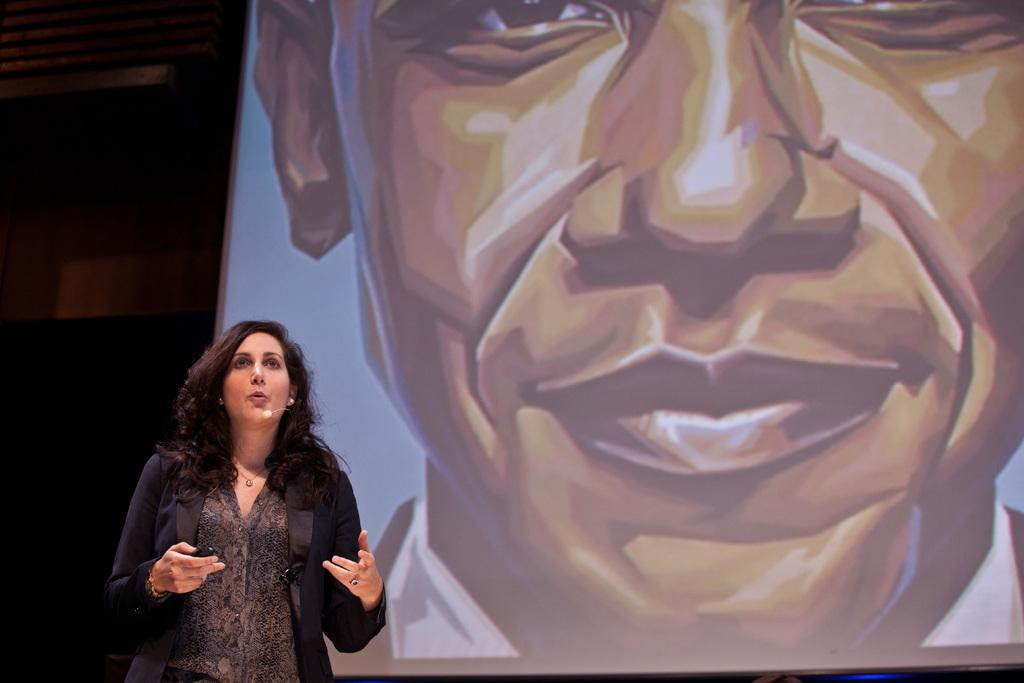What is the lady doing in the image? The lady is standing on the left side of the image. What is the lady holding in the image? The lady is holding an object in the image. What can be seen in the background of the image? There is a screen and a wall in the background of the image. How does the lady compare the size of the knot in the image? There is no knot present in the image, so it cannot be compared. 